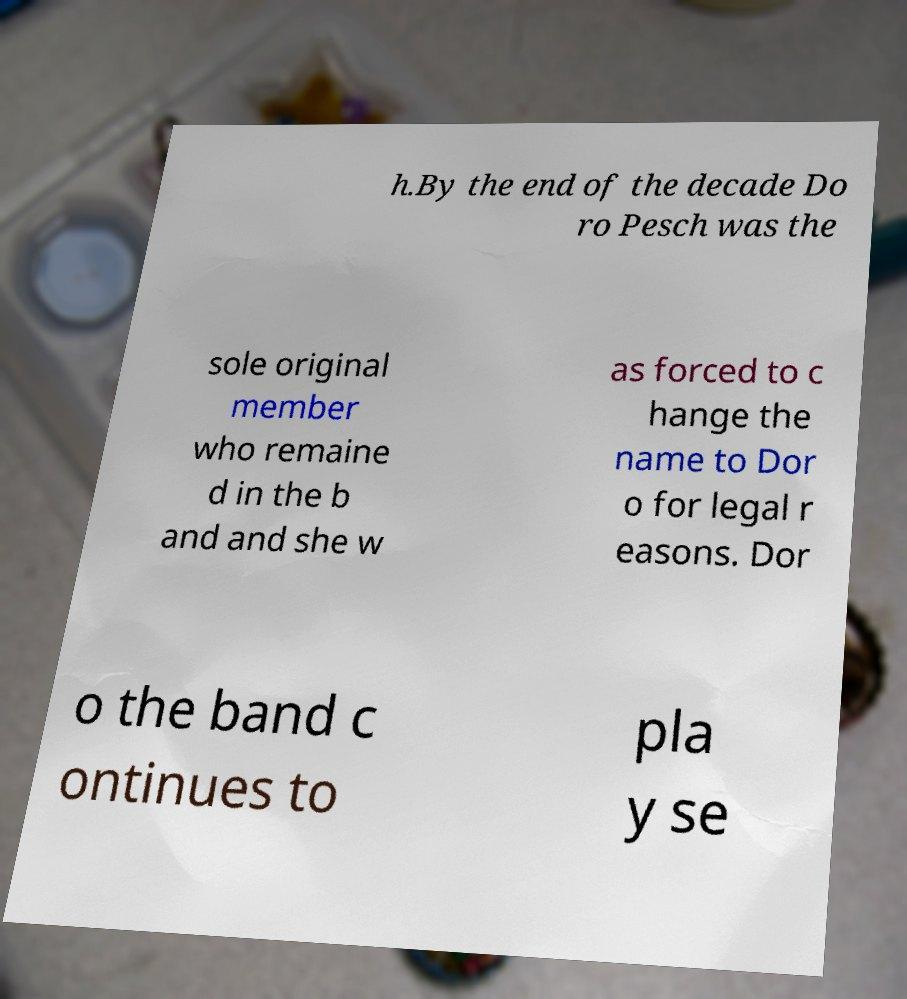Can you read and provide the text displayed in the image?This photo seems to have some interesting text. Can you extract and type it out for me? h.By the end of the decade Do ro Pesch was the sole original member who remaine d in the b and and she w as forced to c hange the name to Dor o for legal r easons. Dor o the band c ontinues to pla y se 